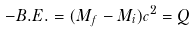Convert formula to latex. <formula><loc_0><loc_0><loc_500><loc_500>- B . E . = ( M _ { f } - M _ { i } ) c ^ { 2 } = Q</formula> 